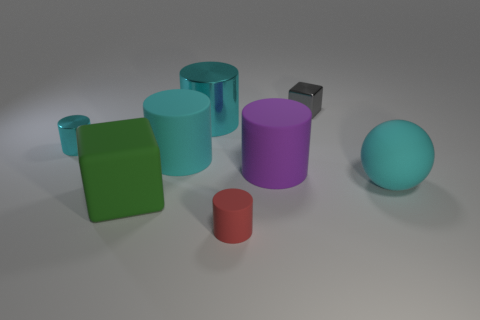There is a rubber sphere to the right of the big cyan metallic object; does it have the same color as the small metal object that is in front of the tiny gray shiny cube?
Your response must be concise. Yes. Is there a large cyan rubber thing that has the same shape as the gray thing?
Provide a succinct answer. No. There is a gray object that is the same size as the red cylinder; what is its shape?
Make the answer very short. Cube. How many large metallic cylinders are the same color as the matte sphere?
Give a very brief answer. 1. What size is the thing that is right of the tiny block?
Offer a terse response. Large. What number of cyan matte cylinders are the same size as the rubber cube?
Ensure brevity in your answer.  1. There is a small cylinder that is made of the same material as the ball; what is its color?
Offer a very short reply. Red. Are there fewer cylinders that are behind the sphere than small green blocks?
Your answer should be very brief. No. There is a big thing that is made of the same material as the small block; what shape is it?
Your answer should be compact. Cylinder. How many shiny things are either blocks or brown blocks?
Your answer should be compact. 1. 